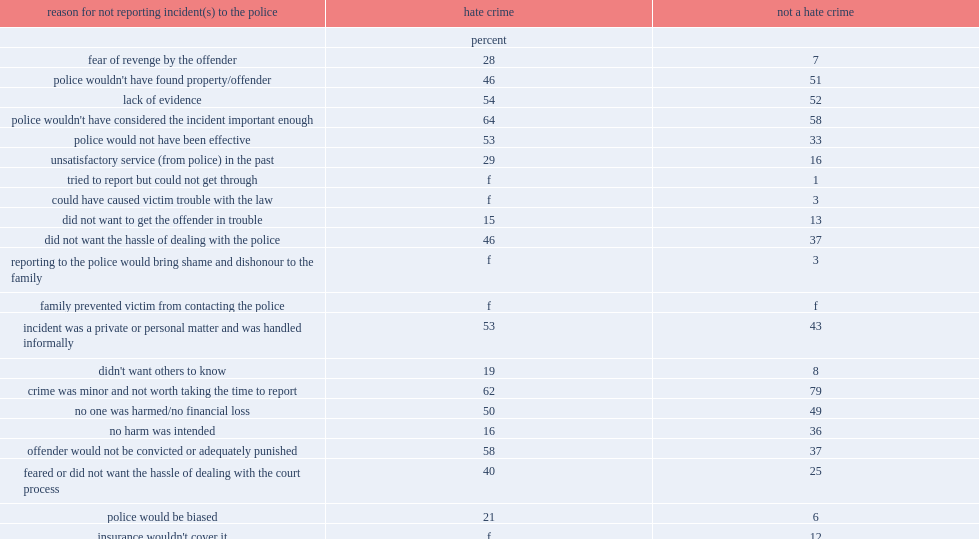What was the percentage of individuals who said they had been victims of hate-motivated incidents did not report the incidents to the police? 64.0. Of the victims who did not report the hate crime targeting them, what was the percentage of victimes said they did not report it because they thought the police would not have considered the incident important enough? 64.0. What was the percentage of individuals who said they had been victims of hate-motivated incidents felt that the crime was minor and not worth taking the time to report to the police? 62.0. What was the percentage of hate-motivated victims cited the belief that the accused would not be convicted or adequately punished? 58.0. What was the percentage of victims of hate crimes said they did not report the crime because they believed the police would not have been effective? 53.0. What was the percentage of victims of non-hate crimes said they did not report the crime because they believed the police would not have been effective? 33.0. What was the percentage of victims of hate crimes did not go to the police because they believed the accused would not be convicted or adequately punished? 58.0. What was the percentage of victims of non-hate crimes did not go to the police because they believed the accused would not be convicted or adequately punished? 37.0. What was the percentage of victims of hate crimes did not report the crime because they either feared the court process or did not want the hassle of dealing with the court process? 40.0. What was the percentage of non-hate crimes did not report the crime because they either feared the court process or did not want the hassle of dealing with the court process? 25.0. 